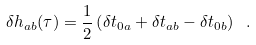Convert formula to latex. <formula><loc_0><loc_0><loc_500><loc_500>\delta h _ { a b } ( \tau ) = \frac { 1 } { 2 } \left ( \delta t _ { 0 a } + \delta t _ { a b } - \delta t _ { 0 b } \right ) \ .</formula> 